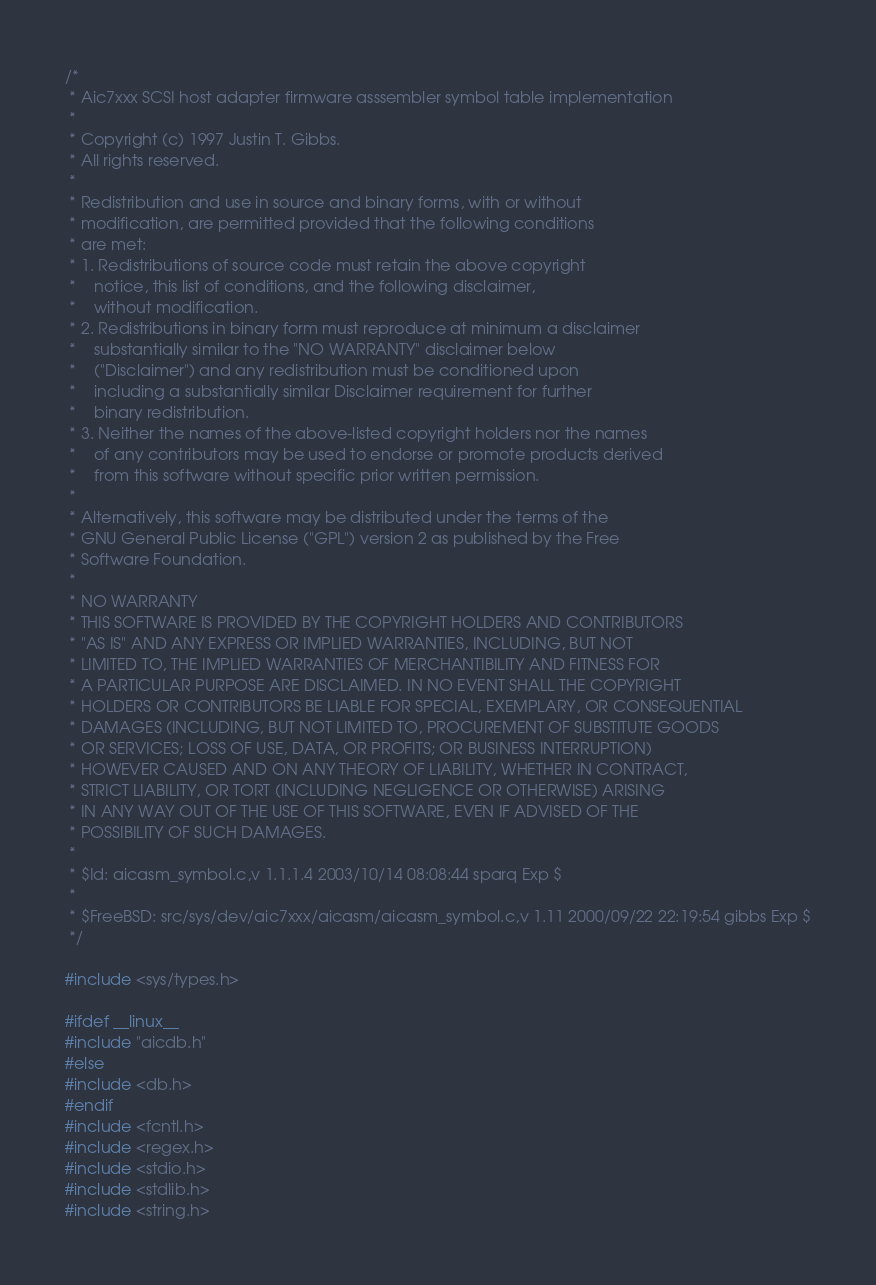Convert code to text. <code><loc_0><loc_0><loc_500><loc_500><_C_>/*
 * Aic7xxx SCSI host adapter firmware asssembler symbol table implementation
 *
 * Copyright (c) 1997 Justin T. Gibbs.
 * All rights reserved.
 *
 * Redistribution and use in source and binary forms, with or without
 * modification, are permitted provided that the following conditions
 * are met:
 * 1. Redistributions of source code must retain the above copyright
 *    notice, this list of conditions, and the following disclaimer,
 *    without modification.
 * 2. Redistributions in binary form must reproduce at minimum a disclaimer
 *    substantially similar to the "NO WARRANTY" disclaimer below
 *    ("Disclaimer") and any redistribution must be conditioned upon
 *    including a substantially similar Disclaimer requirement for further
 *    binary redistribution.
 * 3. Neither the names of the above-listed copyright holders nor the names
 *    of any contributors may be used to endorse or promote products derived
 *    from this software without specific prior written permission.
 *
 * Alternatively, this software may be distributed under the terms of the
 * GNU General Public License ("GPL") version 2 as published by the Free
 * Software Foundation.
 *
 * NO WARRANTY
 * THIS SOFTWARE IS PROVIDED BY THE COPYRIGHT HOLDERS AND CONTRIBUTORS
 * "AS IS" AND ANY EXPRESS OR IMPLIED WARRANTIES, INCLUDING, BUT NOT
 * LIMITED TO, THE IMPLIED WARRANTIES OF MERCHANTIBILITY AND FITNESS FOR
 * A PARTICULAR PURPOSE ARE DISCLAIMED. IN NO EVENT SHALL THE COPYRIGHT
 * HOLDERS OR CONTRIBUTORS BE LIABLE FOR SPECIAL, EXEMPLARY, OR CONSEQUENTIAL
 * DAMAGES (INCLUDING, BUT NOT LIMITED TO, PROCUREMENT OF SUBSTITUTE GOODS
 * OR SERVICES; LOSS OF USE, DATA, OR PROFITS; OR BUSINESS INTERRUPTION)
 * HOWEVER CAUSED AND ON ANY THEORY OF LIABILITY, WHETHER IN CONTRACT,
 * STRICT LIABILITY, OR TORT (INCLUDING NEGLIGENCE OR OTHERWISE) ARISING
 * IN ANY WAY OUT OF THE USE OF THIS SOFTWARE, EVEN IF ADVISED OF THE
 * POSSIBILITY OF SUCH DAMAGES.
 *
 * $Id: aicasm_symbol.c,v 1.1.1.4 2003/10/14 08:08:44 sparq Exp $
 *
 * $FreeBSD: src/sys/dev/aic7xxx/aicasm/aicasm_symbol.c,v 1.11 2000/09/22 22:19:54 gibbs Exp $
 */

#include <sys/types.h>

#ifdef __linux__
#include "aicdb.h"
#else
#include <db.h>
#endif
#include <fcntl.h>
#include <regex.h>
#include <stdio.h>
#include <stdlib.h>
#include <string.h></code> 